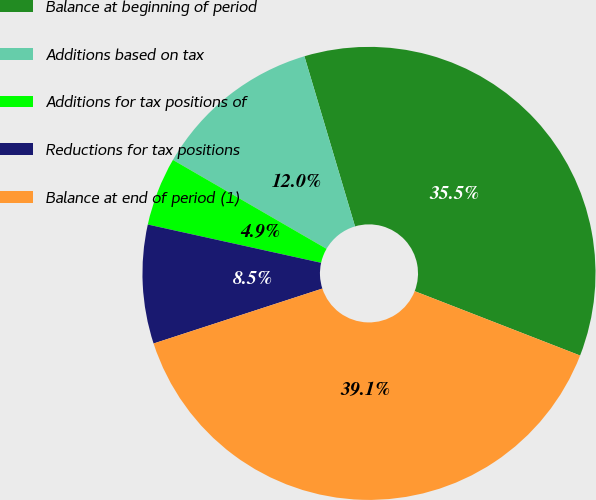<chart> <loc_0><loc_0><loc_500><loc_500><pie_chart><fcel>Balance at beginning of period<fcel>Additions based on tax<fcel>Additions for tax positions of<fcel>Reductions for tax positions<fcel>Balance at end of period (1)<nl><fcel>35.51%<fcel>12.05%<fcel>4.89%<fcel>8.47%<fcel>39.09%<nl></chart> 